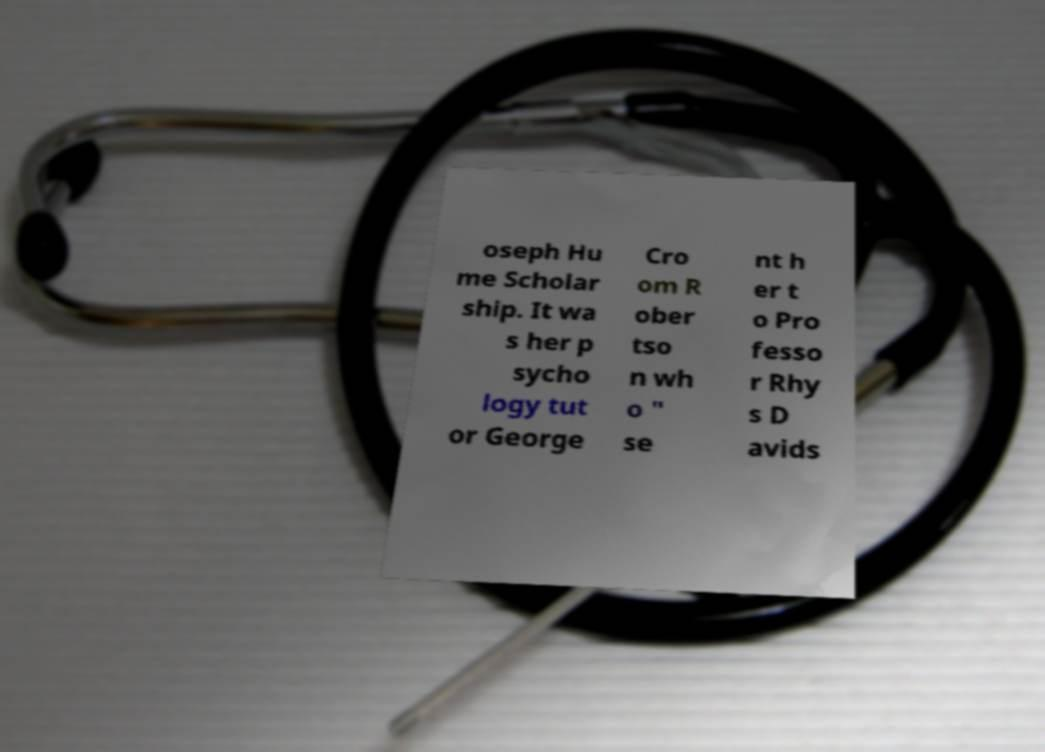Can you accurately transcribe the text from the provided image for me? oseph Hu me Scholar ship. It wa s her p sycho logy tut or George Cro om R ober tso n wh o " se nt h er t o Pro fesso r Rhy s D avids 